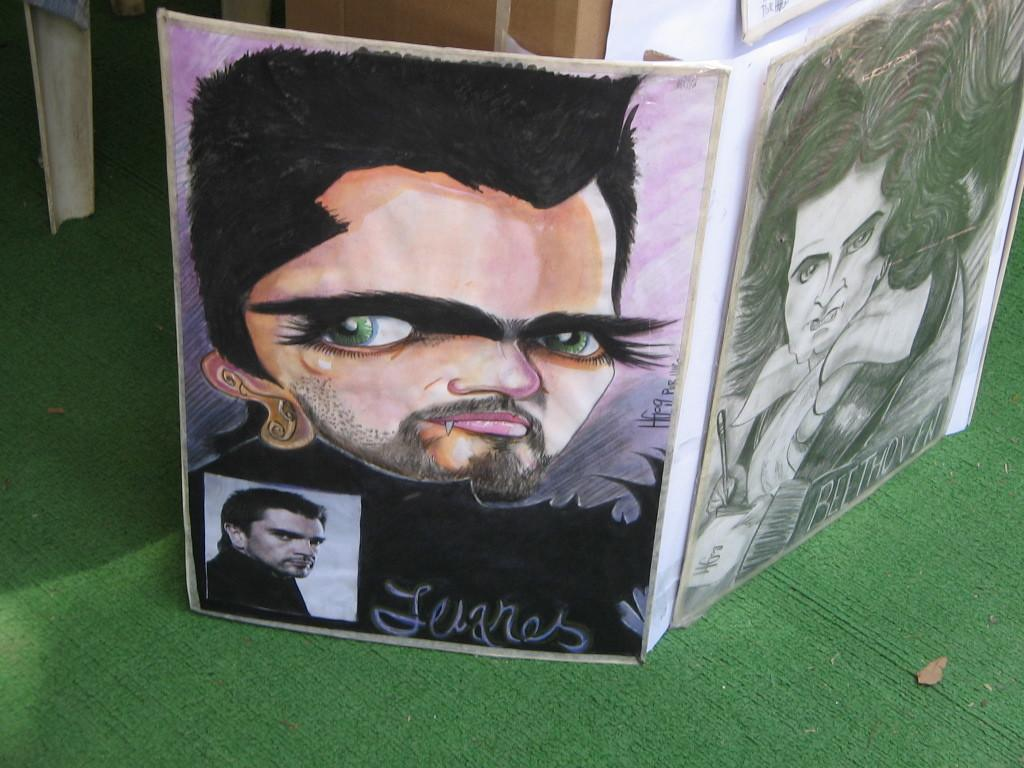What is the main object in the picture? There is a board in the picture. What is on the board? There is a painting on the board. What type of steel is used to create the frame of the painting in the image? There is no mention of steel or a frame in the image, so it cannot be determined from the picture. 